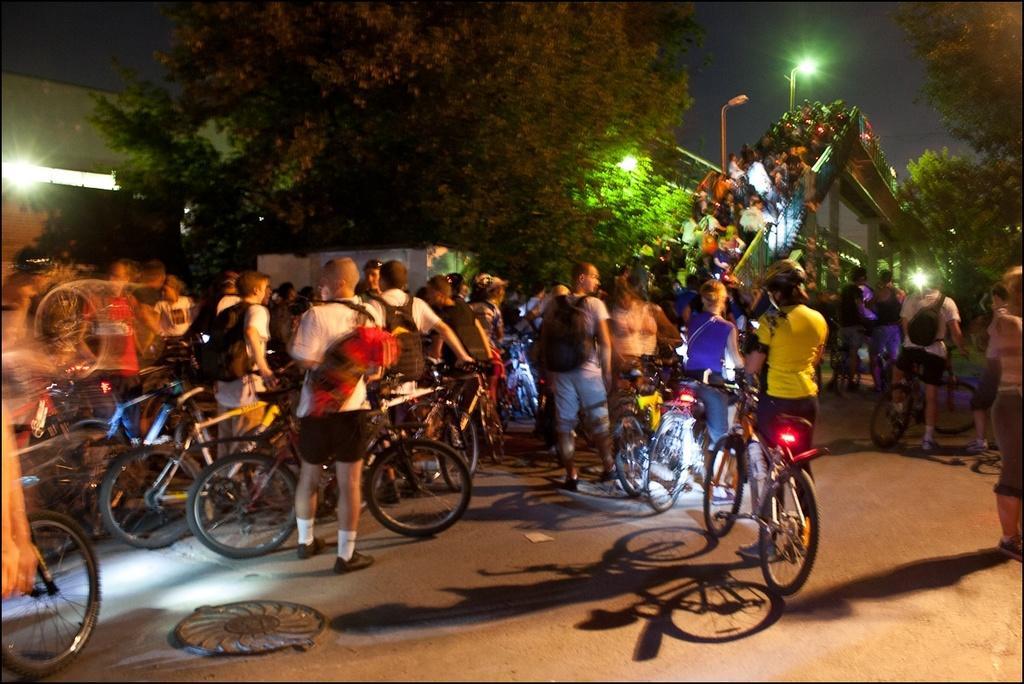Can you describe this image briefly? In this image we can see many people carrying a bicycle. This is the bridge way. In the background of the image we can see few trees, street lights and sky. 